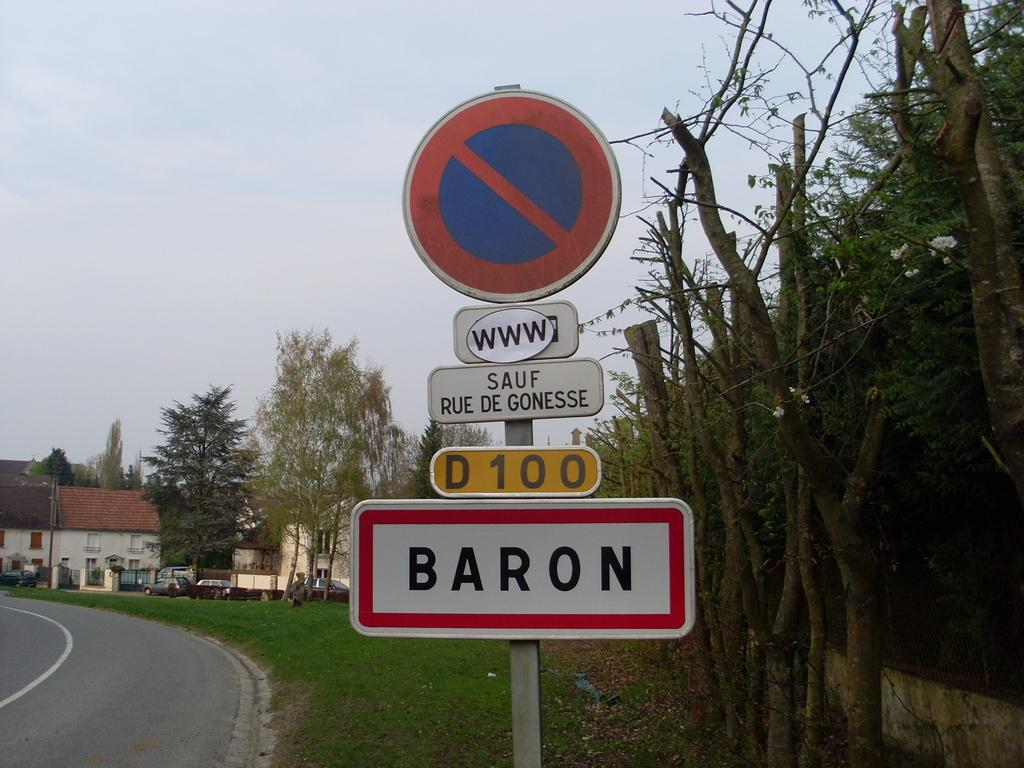<image>
Render a clear and concise summary of the photo. A sign beside a street with Baron and D100 on the pole. 